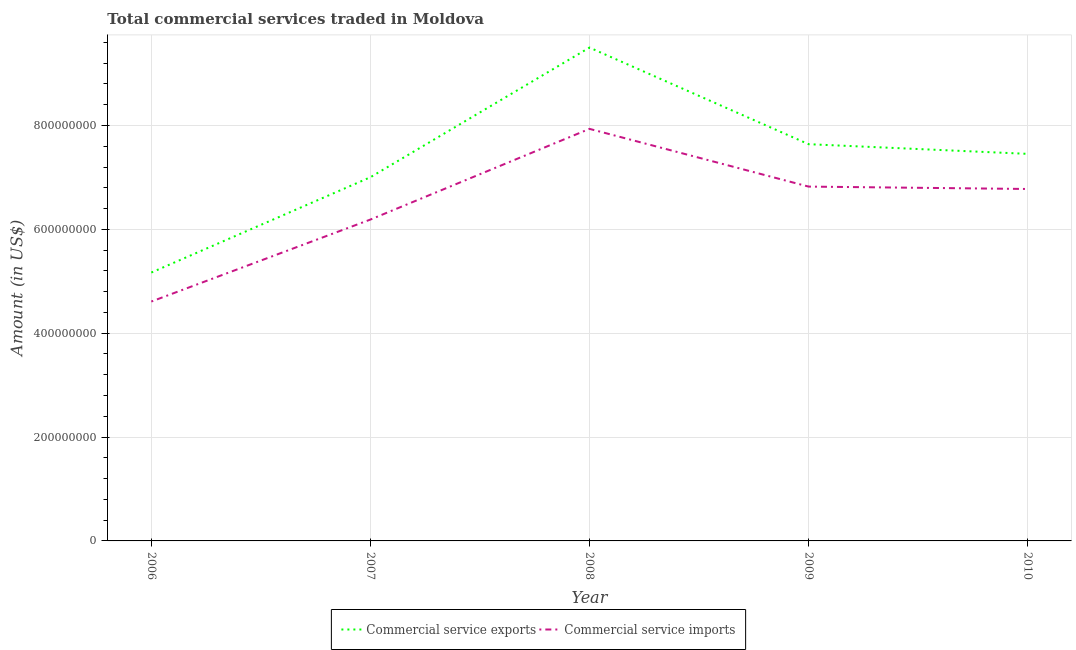Does the line corresponding to amount of commercial service exports intersect with the line corresponding to amount of commercial service imports?
Your answer should be compact. No. What is the amount of commercial service exports in 2009?
Provide a short and direct response. 7.64e+08. Across all years, what is the maximum amount of commercial service exports?
Offer a very short reply. 9.50e+08. Across all years, what is the minimum amount of commercial service imports?
Your answer should be very brief. 4.61e+08. In which year was the amount of commercial service imports maximum?
Your response must be concise. 2008. In which year was the amount of commercial service imports minimum?
Your response must be concise. 2006. What is the total amount of commercial service imports in the graph?
Your response must be concise. 3.23e+09. What is the difference between the amount of commercial service exports in 2008 and that in 2010?
Your answer should be compact. 2.05e+08. What is the difference between the amount of commercial service imports in 2007 and the amount of commercial service exports in 2008?
Give a very brief answer. -3.31e+08. What is the average amount of commercial service exports per year?
Provide a short and direct response. 7.35e+08. In the year 2006, what is the difference between the amount of commercial service exports and amount of commercial service imports?
Offer a very short reply. 5.58e+07. What is the ratio of the amount of commercial service exports in 2008 to that in 2010?
Provide a short and direct response. 1.27. Is the amount of commercial service imports in 2006 less than that in 2009?
Make the answer very short. Yes. What is the difference between the highest and the second highest amount of commercial service exports?
Keep it short and to the point. 1.86e+08. What is the difference between the highest and the lowest amount of commercial service exports?
Keep it short and to the point. 4.33e+08. In how many years, is the amount of commercial service exports greater than the average amount of commercial service exports taken over all years?
Provide a succinct answer. 3. Is the amount of commercial service imports strictly greater than the amount of commercial service exports over the years?
Keep it short and to the point. No. How many lines are there?
Your response must be concise. 2. How many years are there in the graph?
Ensure brevity in your answer.  5. Are the values on the major ticks of Y-axis written in scientific E-notation?
Your answer should be very brief. No. Does the graph contain grids?
Ensure brevity in your answer.  Yes. Where does the legend appear in the graph?
Provide a succinct answer. Bottom center. How many legend labels are there?
Your answer should be compact. 2. What is the title of the graph?
Ensure brevity in your answer.  Total commercial services traded in Moldova. What is the label or title of the Y-axis?
Provide a succinct answer. Amount (in US$). What is the Amount (in US$) in Commercial service exports in 2006?
Your answer should be very brief. 5.17e+08. What is the Amount (in US$) of Commercial service imports in 2006?
Provide a succinct answer. 4.61e+08. What is the Amount (in US$) of Commercial service exports in 2007?
Your answer should be compact. 7.00e+08. What is the Amount (in US$) in Commercial service imports in 2007?
Give a very brief answer. 6.19e+08. What is the Amount (in US$) in Commercial service exports in 2008?
Make the answer very short. 9.50e+08. What is the Amount (in US$) in Commercial service imports in 2008?
Your response must be concise. 7.94e+08. What is the Amount (in US$) in Commercial service exports in 2009?
Provide a short and direct response. 7.64e+08. What is the Amount (in US$) in Commercial service imports in 2009?
Your response must be concise. 6.82e+08. What is the Amount (in US$) of Commercial service exports in 2010?
Offer a terse response. 7.45e+08. What is the Amount (in US$) in Commercial service imports in 2010?
Make the answer very short. 6.78e+08. Across all years, what is the maximum Amount (in US$) in Commercial service exports?
Keep it short and to the point. 9.50e+08. Across all years, what is the maximum Amount (in US$) of Commercial service imports?
Make the answer very short. 7.94e+08. Across all years, what is the minimum Amount (in US$) in Commercial service exports?
Make the answer very short. 5.17e+08. Across all years, what is the minimum Amount (in US$) in Commercial service imports?
Make the answer very short. 4.61e+08. What is the total Amount (in US$) in Commercial service exports in the graph?
Offer a terse response. 3.68e+09. What is the total Amount (in US$) in Commercial service imports in the graph?
Offer a very short reply. 3.23e+09. What is the difference between the Amount (in US$) in Commercial service exports in 2006 and that in 2007?
Your answer should be very brief. -1.84e+08. What is the difference between the Amount (in US$) of Commercial service imports in 2006 and that in 2007?
Your response must be concise. -1.58e+08. What is the difference between the Amount (in US$) in Commercial service exports in 2006 and that in 2008?
Ensure brevity in your answer.  -4.33e+08. What is the difference between the Amount (in US$) of Commercial service imports in 2006 and that in 2008?
Your response must be concise. -3.33e+08. What is the difference between the Amount (in US$) in Commercial service exports in 2006 and that in 2009?
Your response must be concise. -2.47e+08. What is the difference between the Amount (in US$) of Commercial service imports in 2006 and that in 2009?
Ensure brevity in your answer.  -2.21e+08. What is the difference between the Amount (in US$) of Commercial service exports in 2006 and that in 2010?
Provide a short and direct response. -2.29e+08. What is the difference between the Amount (in US$) in Commercial service imports in 2006 and that in 2010?
Provide a succinct answer. -2.17e+08. What is the difference between the Amount (in US$) of Commercial service exports in 2007 and that in 2008?
Provide a short and direct response. -2.50e+08. What is the difference between the Amount (in US$) in Commercial service imports in 2007 and that in 2008?
Provide a succinct answer. -1.75e+08. What is the difference between the Amount (in US$) in Commercial service exports in 2007 and that in 2009?
Make the answer very short. -6.36e+07. What is the difference between the Amount (in US$) of Commercial service imports in 2007 and that in 2009?
Your answer should be compact. -6.35e+07. What is the difference between the Amount (in US$) in Commercial service exports in 2007 and that in 2010?
Ensure brevity in your answer.  -4.50e+07. What is the difference between the Amount (in US$) in Commercial service imports in 2007 and that in 2010?
Provide a short and direct response. -5.89e+07. What is the difference between the Amount (in US$) of Commercial service exports in 2008 and that in 2009?
Offer a very short reply. 1.86e+08. What is the difference between the Amount (in US$) in Commercial service imports in 2008 and that in 2009?
Keep it short and to the point. 1.11e+08. What is the difference between the Amount (in US$) in Commercial service exports in 2008 and that in 2010?
Give a very brief answer. 2.05e+08. What is the difference between the Amount (in US$) of Commercial service imports in 2008 and that in 2010?
Your answer should be compact. 1.16e+08. What is the difference between the Amount (in US$) in Commercial service exports in 2009 and that in 2010?
Keep it short and to the point. 1.86e+07. What is the difference between the Amount (in US$) in Commercial service imports in 2009 and that in 2010?
Your answer should be very brief. 4.61e+06. What is the difference between the Amount (in US$) of Commercial service exports in 2006 and the Amount (in US$) of Commercial service imports in 2007?
Keep it short and to the point. -1.02e+08. What is the difference between the Amount (in US$) of Commercial service exports in 2006 and the Amount (in US$) of Commercial service imports in 2008?
Your answer should be very brief. -2.77e+08. What is the difference between the Amount (in US$) in Commercial service exports in 2006 and the Amount (in US$) in Commercial service imports in 2009?
Your response must be concise. -1.66e+08. What is the difference between the Amount (in US$) of Commercial service exports in 2006 and the Amount (in US$) of Commercial service imports in 2010?
Ensure brevity in your answer.  -1.61e+08. What is the difference between the Amount (in US$) in Commercial service exports in 2007 and the Amount (in US$) in Commercial service imports in 2008?
Give a very brief answer. -9.31e+07. What is the difference between the Amount (in US$) of Commercial service exports in 2007 and the Amount (in US$) of Commercial service imports in 2009?
Offer a terse response. 1.80e+07. What is the difference between the Amount (in US$) of Commercial service exports in 2007 and the Amount (in US$) of Commercial service imports in 2010?
Offer a very short reply. 2.26e+07. What is the difference between the Amount (in US$) in Commercial service exports in 2008 and the Amount (in US$) in Commercial service imports in 2009?
Your response must be concise. 2.68e+08. What is the difference between the Amount (in US$) of Commercial service exports in 2008 and the Amount (in US$) of Commercial service imports in 2010?
Your answer should be compact. 2.72e+08. What is the difference between the Amount (in US$) in Commercial service exports in 2009 and the Amount (in US$) in Commercial service imports in 2010?
Give a very brief answer. 8.63e+07. What is the average Amount (in US$) in Commercial service exports per year?
Offer a very short reply. 7.35e+08. What is the average Amount (in US$) of Commercial service imports per year?
Your answer should be compact. 6.47e+08. In the year 2006, what is the difference between the Amount (in US$) of Commercial service exports and Amount (in US$) of Commercial service imports?
Provide a short and direct response. 5.58e+07. In the year 2007, what is the difference between the Amount (in US$) of Commercial service exports and Amount (in US$) of Commercial service imports?
Make the answer very short. 8.15e+07. In the year 2008, what is the difference between the Amount (in US$) in Commercial service exports and Amount (in US$) in Commercial service imports?
Your answer should be compact. 1.57e+08. In the year 2009, what is the difference between the Amount (in US$) of Commercial service exports and Amount (in US$) of Commercial service imports?
Your answer should be compact. 8.17e+07. In the year 2010, what is the difference between the Amount (in US$) of Commercial service exports and Amount (in US$) of Commercial service imports?
Provide a succinct answer. 6.76e+07. What is the ratio of the Amount (in US$) of Commercial service exports in 2006 to that in 2007?
Provide a short and direct response. 0.74. What is the ratio of the Amount (in US$) of Commercial service imports in 2006 to that in 2007?
Give a very brief answer. 0.74. What is the ratio of the Amount (in US$) in Commercial service exports in 2006 to that in 2008?
Your answer should be compact. 0.54. What is the ratio of the Amount (in US$) in Commercial service imports in 2006 to that in 2008?
Your response must be concise. 0.58. What is the ratio of the Amount (in US$) in Commercial service exports in 2006 to that in 2009?
Give a very brief answer. 0.68. What is the ratio of the Amount (in US$) in Commercial service imports in 2006 to that in 2009?
Your answer should be compact. 0.68. What is the ratio of the Amount (in US$) in Commercial service exports in 2006 to that in 2010?
Ensure brevity in your answer.  0.69. What is the ratio of the Amount (in US$) of Commercial service imports in 2006 to that in 2010?
Provide a succinct answer. 0.68. What is the ratio of the Amount (in US$) in Commercial service exports in 2007 to that in 2008?
Offer a very short reply. 0.74. What is the ratio of the Amount (in US$) of Commercial service imports in 2007 to that in 2008?
Keep it short and to the point. 0.78. What is the ratio of the Amount (in US$) in Commercial service imports in 2007 to that in 2009?
Provide a short and direct response. 0.91. What is the ratio of the Amount (in US$) of Commercial service exports in 2007 to that in 2010?
Give a very brief answer. 0.94. What is the ratio of the Amount (in US$) in Commercial service imports in 2007 to that in 2010?
Provide a short and direct response. 0.91. What is the ratio of the Amount (in US$) of Commercial service exports in 2008 to that in 2009?
Ensure brevity in your answer.  1.24. What is the ratio of the Amount (in US$) in Commercial service imports in 2008 to that in 2009?
Ensure brevity in your answer.  1.16. What is the ratio of the Amount (in US$) in Commercial service exports in 2008 to that in 2010?
Give a very brief answer. 1.27. What is the ratio of the Amount (in US$) of Commercial service imports in 2008 to that in 2010?
Offer a very short reply. 1.17. What is the ratio of the Amount (in US$) in Commercial service exports in 2009 to that in 2010?
Your response must be concise. 1.02. What is the ratio of the Amount (in US$) of Commercial service imports in 2009 to that in 2010?
Provide a short and direct response. 1.01. What is the difference between the highest and the second highest Amount (in US$) in Commercial service exports?
Provide a short and direct response. 1.86e+08. What is the difference between the highest and the second highest Amount (in US$) in Commercial service imports?
Your answer should be compact. 1.11e+08. What is the difference between the highest and the lowest Amount (in US$) in Commercial service exports?
Your answer should be compact. 4.33e+08. What is the difference between the highest and the lowest Amount (in US$) in Commercial service imports?
Provide a short and direct response. 3.33e+08. 